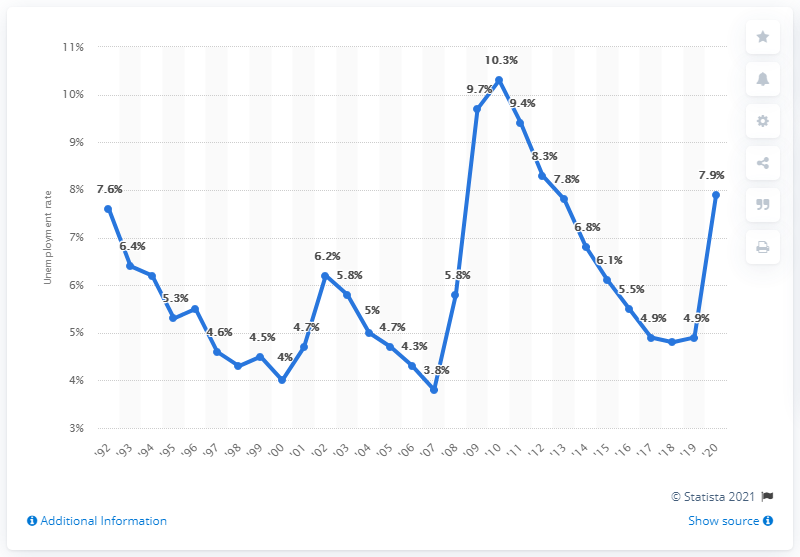Highlight a few significant elements in this photo. Arizona's highest unemployment rate in 2010 was 10.3%. According to data from 2010, the unemployment rate in Arizona was 4.9%. 